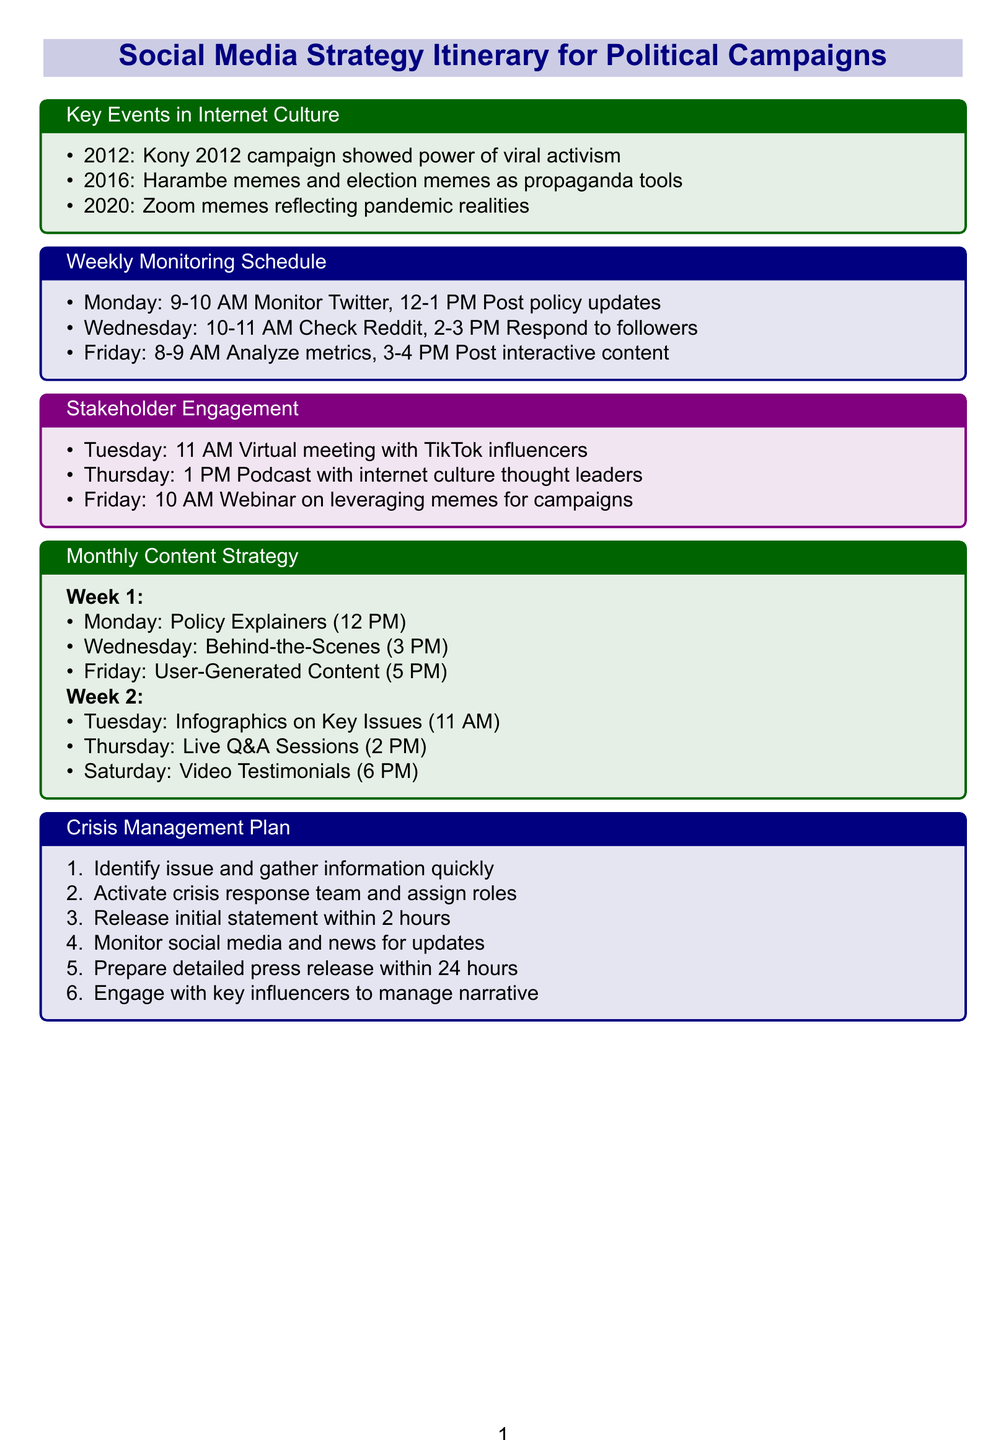What year did the Kony 2012 campaign occur? The Kony 2012 campaign is listed under key events in internet culture in the document, which specifies the year as 2012.
Answer: 2012 What type of content is scheduled for Tuesday of Week 2? The document details the content strategy, specifying that infographics on key issues will be posted on Tuesday of Week 2.
Answer: Infographics on Key Issues How long is the scheduled weekly monitoring time for analyzing metrics? The document specifies an hour-long slot for analyzing metrics on Friday from 8 to 9 AM.
Answer: 1 hour What is the initial response time defined in the crisis management plan? The crisis management plan states the initial statement should be released within 2 hours after the issue is identified.
Answer: 2 hours Which platform has a virtual meeting scheduled with influencers? The document indicates that there is a virtual meeting with TikTok influencers, mentioned in the stakeholder engagement section.
Answer: TikTok 